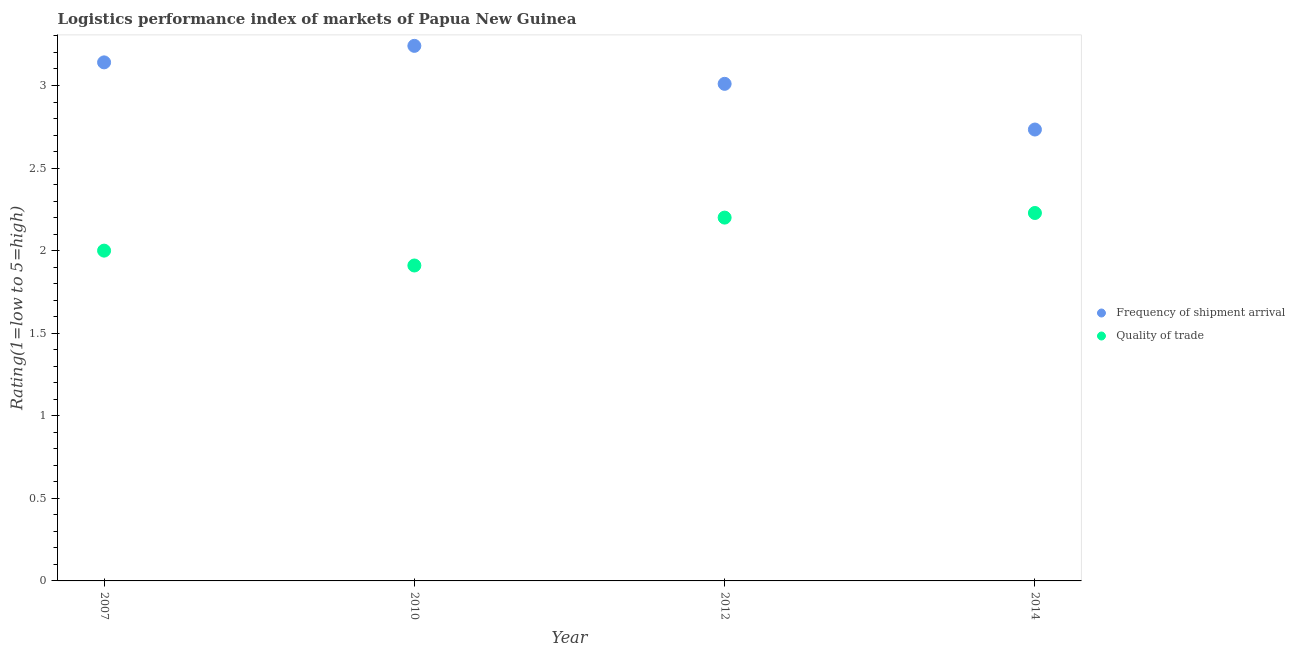Is the number of dotlines equal to the number of legend labels?
Your answer should be very brief. Yes. Across all years, what is the maximum lpi quality of trade?
Offer a terse response. 2.23. Across all years, what is the minimum lpi quality of trade?
Keep it short and to the point. 1.91. In which year was the lpi of frequency of shipment arrival maximum?
Provide a short and direct response. 2010. In which year was the lpi quality of trade minimum?
Provide a succinct answer. 2010. What is the total lpi of frequency of shipment arrival in the graph?
Offer a very short reply. 12.12. What is the difference between the lpi of frequency of shipment arrival in 2010 and that in 2014?
Your answer should be compact. 0.51. What is the difference between the lpi quality of trade in 2010 and the lpi of frequency of shipment arrival in 2012?
Make the answer very short. -1.1. What is the average lpi quality of trade per year?
Offer a very short reply. 2.08. In the year 2010, what is the difference between the lpi quality of trade and lpi of frequency of shipment arrival?
Provide a succinct answer. -1.33. In how many years, is the lpi of frequency of shipment arrival greater than 1.6?
Make the answer very short. 4. What is the ratio of the lpi quality of trade in 2012 to that in 2014?
Give a very brief answer. 0.99. Is the lpi of frequency of shipment arrival in 2012 less than that in 2014?
Your response must be concise. No. What is the difference between the highest and the second highest lpi quality of trade?
Your answer should be compact. 0.03. What is the difference between the highest and the lowest lpi of frequency of shipment arrival?
Your response must be concise. 0.51. Is the sum of the lpi quality of trade in 2012 and 2014 greater than the maximum lpi of frequency of shipment arrival across all years?
Your answer should be very brief. Yes. Does the lpi of frequency of shipment arrival monotonically increase over the years?
Give a very brief answer. No. Is the lpi quality of trade strictly greater than the lpi of frequency of shipment arrival over the years?
Provide a succinct answer. No. Is the lpi of frequency of shipment arrival strictly less than the lpi quality of trade over the years?
Make the answer very short. No. How many dotlines are there?
Your response must be concise. 2. What is the difference between two consecutive major ticks on the Y-axis?
Your answer should be very brief. 0.5. Are the values on the major ticks of Y-axis written in scientific E-notation?
Your response must be concise. No. How many legend labels are there?
Offer a terse response. 2. How are the legend labels stacked?
Offer a very short reply. Vertical. What is the title of the graph?
Provide a succinct answer. Logistics performance index of markets of Papua New Guinea. What is the label or title of the X-axis?
Your answer should be compact. Year. What is the label or title of the Y-axis?
Make the answer very short. Rating(1=low to 5=high). What is the Rating(1=low to 5=high) of Frequency of shipment arrival in 2007?
Your answer should be very brief. 3.14. What is the Rating(1=low to 5=high) in Frequency of shipment arrival in 2010?
Make the answer very short. 3.24. What is the Rating(1=low to 5=high) in Quality of trade in 2010?
Give a very brief answer. 1.91. What is the Rating(1=low to 5=high) in Frequency of shipment arrival in 2012?
Provide a succinct answer. 3.01. What is the Rating(1=low to 5=high) of Frequency of shipment arrival in 2014?
Your answer should be very brief. 2.73. What is the Rating(1=low to 5=high) in Quality of trade in 2014?
Keep it short and to the point. 2.23. Across all years, what is the maximum Rating(1=low to 5=high) of Frequency of shipment arrival?
Provide a short and direct response. 3.24. Across all years, what is the maximum Rating(1=low to 5=high) in Quality of trade?
Your answer should be compact. 2.23. Across all years, what is the minimum Rating(1=low to 5=high) in Frequency of shipment arrival?
Provide a short and direct response. 2.73. Across all years, what is the minimum Rating(1=low to 5=high) in Quality of trade?
Your answer should be very brief. 1.91. What is the total Rating(1=low to 5=high) of Frequency of shipment arrival in the graph?
Keep it short and to the point. 12.12. What is the total Rating(1=low to 5=high) in Quality of trade in the graph?
Your answer should be very brief. 8.34. What is the difference between the Rating(1=low to 5=high) in Frequency of shipment arrival in 2007 and that in 2010?
Keep it short and to the point. -0.1. What is the difference between the Rating(1=low to 5=high) of Quality of trade in 2007 and that in 2010?
Give a very brief answer. 0.09. What is the difference between the Rating(1=low to 5=high) of Frequency of shipment arrival in 2007 and that in 2012?
Provide a succinct answer. 0.13. What is the difference between the Rating(1=low to 5=high) of Quality of trade in 2007 and that in 2012?
Provide a succinct answer. -0.2. What is the difference between the Rating(1=low to 5=high) in Frequency of shipment arrival in 2007 and that in 2014?
Offer a terse response. 0.41. What is the difference between the Rating(1=low to 5=high) of Quality of trade in 2007 and that in 2014?
Give a very brief answer. -0.23. What is the difference between the Rating(1=low to 5=high) in Frequency of shipment arrival in 2010 and that in 2012?
Ensure brevity in your answer.  0.23. What is the difference between the Rating(1=low to 5=high) in Quality of trade in 2010 and that in 2012?
Make the answer very short. -0.29. What is the difference between the Rating(1=low to 5=high) of Frequency of shipment arrival in 2010 and that in 2014?
Provide a succinct answer. 0.51. What is the difference between the Rating(1=low to 5=high) of Quality of trade in 2010 and that in 2014?
Your response must be concise. -0.32. What is the difference between the Rating(1=low to 5=high) in Frequency of shipment arrival in 2012 and that in 2014?
Give a very brief answer. 0.28. What is the difference between the Rating(1=low to 5=high) in Quality of trade in 2012 and that in 2014?
Offer a terse response. -0.03. What is the difference between the Rating(1=low to 5=high) in Frequency of shipment arrival in 2007 and the Rating(1=low to 5=high) in Quality of trade in 2010?
Give a very brief answer. 1.23. What is the difference between the Rating(1=low to 5=high) of Frequency of shipment arrival in 2007 and the Rating(1=low to 5=high) of Quality of trade in 2014?
Your answer should be compact. 0.91. What is the difference between the Rating(1=low to 5=high) of Frequency of shipment arrival in 2010 and the Rating(1=low to 5=high) of Quality of trade in 2012?
Make the answer very short. 1.04. What is the difference between the Rating(1=low to 5=high) in Frequency of shipment arrival in 2010 and the Rating(1=low to 5=high) in Quality of trade in 2014?
Your answer should be compact. 1.01. What is the difference between the Rating(1=low to 5=high) of Frequency of shipment arrival in 2012 and the Rating(1=low to 5=high) of Quality of trade in 2014?
Offer a terse response. 0.78. What is the average Rating(1=low to 5=high) in Frequency of shipment arrival per year?
Make the answer very short. 3.03. What is the average Rating(1=low to 5=high) of Quality of trade per year?
Ensure brevity in your answer.  2.08. In the year 2007, what is the difference between the Rating(1=low to 5=high) of Frequency of shipment arrival and Rating(1=low to 5=high) of Quality of trade?
Give a very brief answer. 1.14. In the year 2010, what is the difference between the Rating(1=low to 5=high) in Frequency of shipment arrival and Rating(1=low to 5=high) in Quality of trade?
Your answer should be compact. 1.33. In the year 2012, what is the difference between the Rating(1=low to 5=high) in Frequency of shipment arrival and Rating(1=low to 5=high) in Quality of trade?
Make the answer very short. 0.81. In the year 2014, what is the difference between the Rating(1=low to 5=high) of Frequency of shipment arrival and Rating(1=low to 5=high) of Quality of trade?
Keep it short and to the point. 0.51. What is the ratio of the Rating(1=low to 5=high) of Frequency of shipment arrival in 2007 to that in 2010?
Make the answer very short. 0.97. What is the ratio of the Rating(1=low to 5=high) in Quality of trade in 2007 to that in 2010?
Provide a succinct answer. 1.05. What is the ratio of the Rating(1=low to 5=high) of Frequency of shipment arrival in 2007 to that in 2012?
Your answer should be very brief. 1.04. What is the ratio of the Rating(1=low to 5=high) of Quality of trade in 2007 to that in 2012?
Provide a short and direct response. 0.91. What is the ratio of the Rating(1=low to 5=high) of Frequency of shipment arrival in 2007 to that in 2014?
Ensure brevity in your answer.  1.15. What is the ratio of the Rating(1=low to 5=high) in Quality of trade in 2007 to that in 2014?
Provide a short and direct response. 0.9. What is the ratio of the Rating(1=low to 5=high) in Frequency of shipment arrival in 2010 to that in 2012?
Provide a short and direct response. 1.08. What is the ratio of the Rating(1=low to 5=high) in Quality of trade in 2010 to that in 2012?
Keep it short and to the point. 0.87. What is the ratio of the Rating(1=low to 5=high) of Frequency of shipment arrival in 2010 to that in 2014?
Keep it short and to the point. 1.19. What is the ratio of the Rating(1=low to 5=high) of Quality of trade in 2010 to that in 2014?
Ensure brevity in your answer.  0.86. What is the ratio of the Rating(1=low to 5=high) of Frequency of shipment arrival in 2012 to that in 2014?
Give a very brief answer. 1.1. What is the ratio of the Rating(1=low to 5=high) in Quality of trade in 2012 to that in 2014?
Offer a terse response. 0.99. What is the difference between the highest and the second highest Rating(1=low to 5=high) of Quality of trade?
Keep it short and to the point. 0.03. What is the difference between the highest and the lowest Rating(1=low to 5=high) of Frequency of shipment arrival?
Give a very brief answer. 0.51. What is the difference between the highest and the lowest Rating(1=low to 5=high) of Quality of trade?
Give a very brief answer. 0.32. 